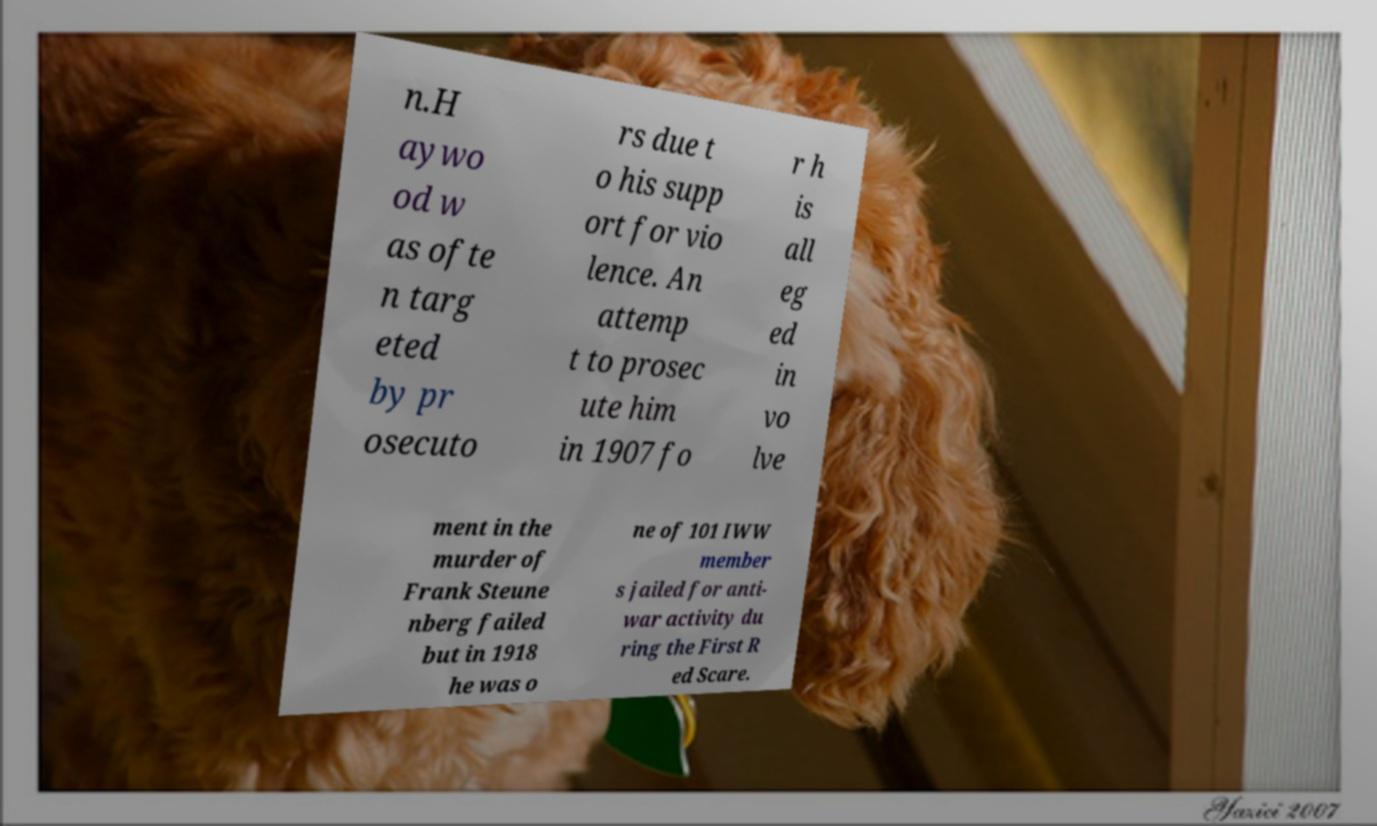What messages or text are displayed in this image? I need them in a readable, typed format. n.H aywo od w as ofte n targ eted by pr osecuto rs due t o his supp ort for vio lence. An attemp t to prosec ute him in 1907 fo r h is all eg ed in vo lve ment in the murder of Frank Steune nberg failed but in 1918 he was o ne of 101 IWW member s jailed for anti- war activity du ring the First R ed Scare. 